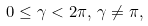Convert formula to latex. <formula><loc_0><loc_0><loc_500><loc_500>0 \leq \gamma < 2 \pi , \, \gamma \neq \pi ,</formula> 